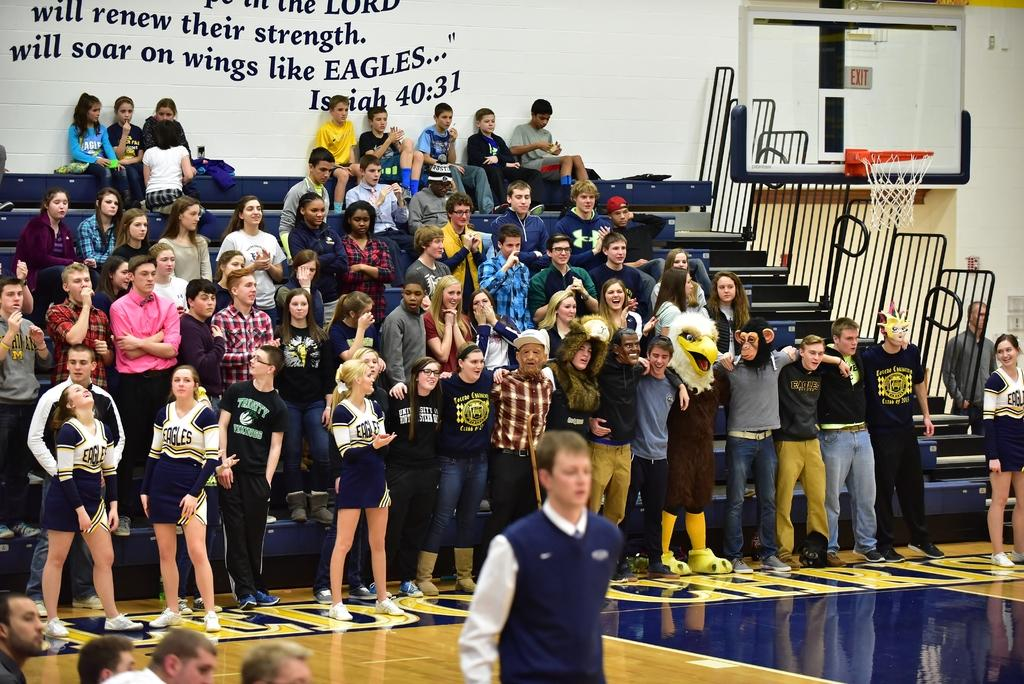<image>
Render a clear and concise summary of the photo. In a school gym, a Bible quote from Isaiah 40:31 is painted on the white cinderblock wall. 